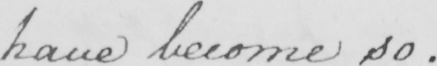What does this handwritten line say? have become so . 